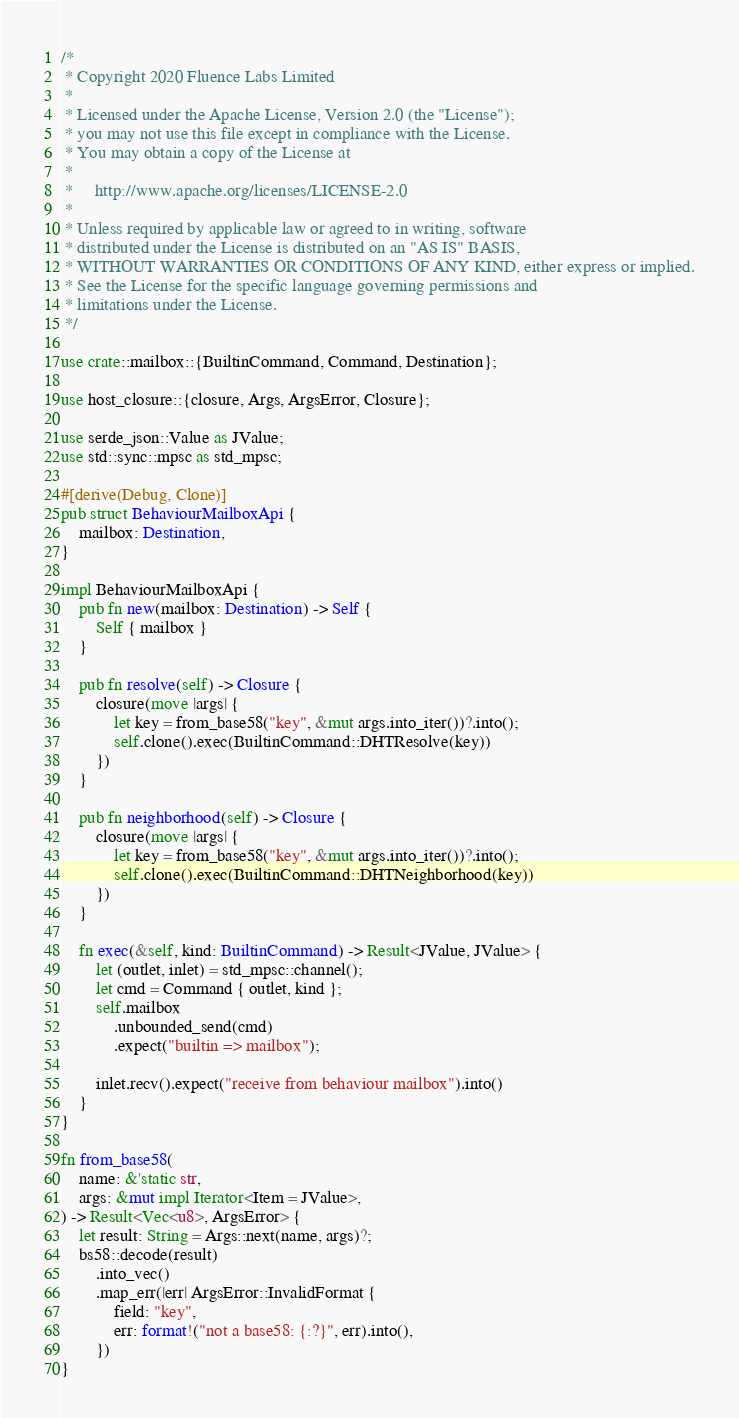<code> <loc_0><loc_0><loc_500><loc_500><_Rust_>/*
 * Copyright 2020 Fluence Labs Limited
 *
 * Licensed under the Apache License, Version 2.0 (the "License");
 * you may not use this file except in compliance with the License.
 * You may obtain a copy of the License at
 *
 *     http://www.apache.org/licenses/LICENSE-2.0
 *
 * Unless required by applicable law or agreed to in writing, software
 * distributed under the License is distributed on an "AS IS" BASIS,
 * WITHOUT WARRANTIES OR CONDITIONS OF ANY KIND, either express or implied.
 * See the License for the specific language governing permissions and
 * limitations under the License.
 */

use crate::mailbox::{BuiltinCommand, Command, Destination};

use host_closure::{closure, Args, ArgsError, Closure};

use serde_json::Value as JValue;
use std::sync::mpsc as std_mpsc;

#[derive(Debug, Clone)]
pub struct BehaviourMailboxApi {
    mailbox: Destination,
}

impl BehaviourMailboxApi {
    pub fn new(mailbox: Destination) -> Self {
        Self { mailbox }
    }

    pub fn resolve(self) -> Closure {
        closure(move |args| {
            let key = from_base58("key", &mut args.into_iter())?.into();
            self.clone().exec(BuiltinCommand::DHTResolve(key))
        })
    }

    pub fn neighborhood(self) -> Closure {
        closure(move |args| {
            let key = from_base58("key", &mut args.into_iter())?.into();
            self.clone().exec(BuiltinCommand::DHTNeighborhood(key))
        })
    }

    fn exec(&self, kind: BuiltinCommand) -> Result<JValue, JValue> {
        let (outlet, inlet) = std_mpsc::channel();
        let cmd = Command { outlet, kind };
        self.mailbox
            .unbounded_send(cmd)
            .expect("builtin => mailbox");

        inlet.recv().expect("receive from behaviour mailbox").into()
    }
}

fn from_base58(
    name: &'static str,
    args: &mut impl Iterator<Item = JValue>,
) -> Result<Vec<u8>, ArgsError> {
    let result: String = Args::next(name, args)?;
    bs58::decode(result)
        .into_vec()
        .map_err(|err| ArgsError::InvalidFormat {
            field: "key",
            err: format!("not a base58: {:?}", err).into(),
        })
}
</code> 